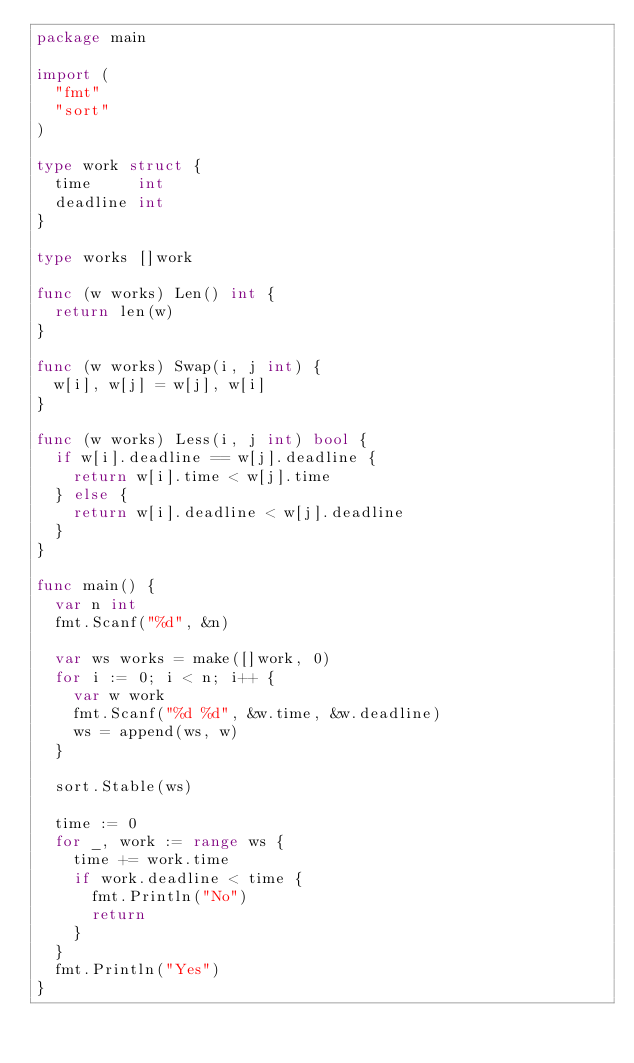Convert code to text. <code><loc_0><loc_0><loc_500><loc_500><_Go_>package main
 
import (
	"fmt"
	"sort"
)
 
type work struct {
	time     int
	deadline int
}
 
type works []work
 
func (w works) Len() int {
	return len(w)
}
 
func (w works) Swap(i, j int) {
	w[i], w[j] = w[j], w[i]
}
 
func (w works) Less(i, j int) bool {
	if w[i].deadline == w[j].deadline {
		return w[i].time < w[j].time
	} else {
		return w[i].deadline < w[j].deadline
	}
}
 
func main() {
	var n int
	fmt.Scanf("%d", &n)
 
	var ws works = make([]work, 0)
	for i := 0; i < n; i++ {
		var w work
		fmt.Scanf("%d %d", &w.time, &w.deadline)
		ws = append(ws, w)
	}
 
	sort.Stable(ws)
 
	time := 0
	for _, work := range ws {
		time += work.time
		if work.deadline < time {
			fmt.Println("No")
			return
		}
	}
	fmt.Println("Yes")
}</code> 